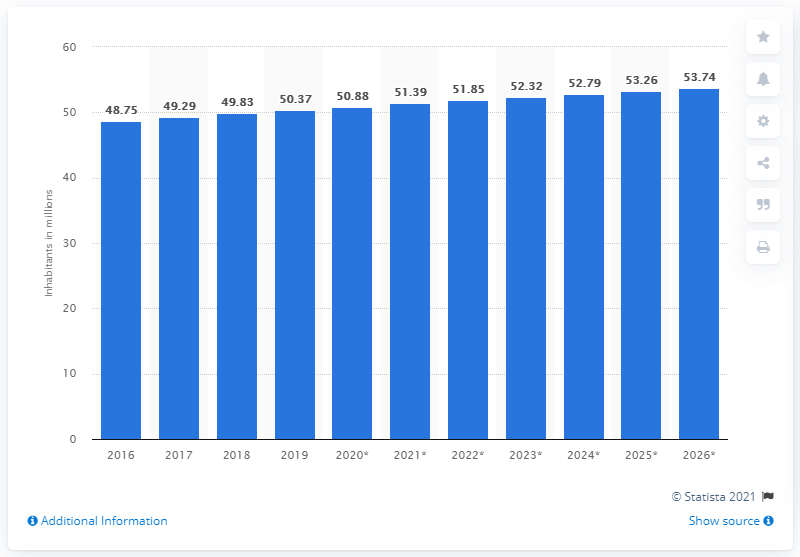Indicate a few pertinent items in this graphic. In 2019, the population of Colombia was approximately 50.37 million people. 